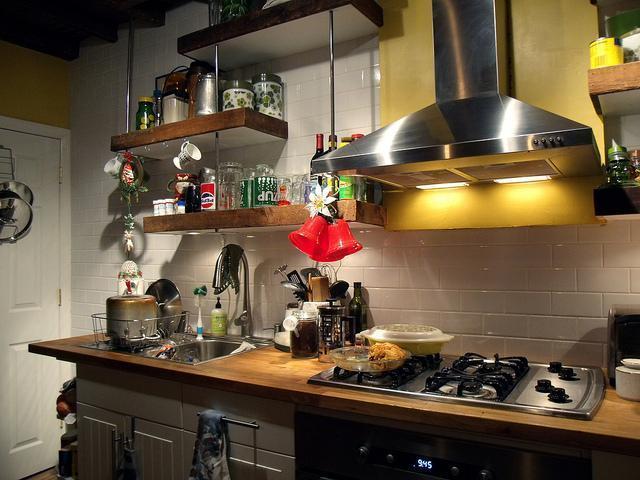How many ovens are there?
Give a very brief answer. 2. 